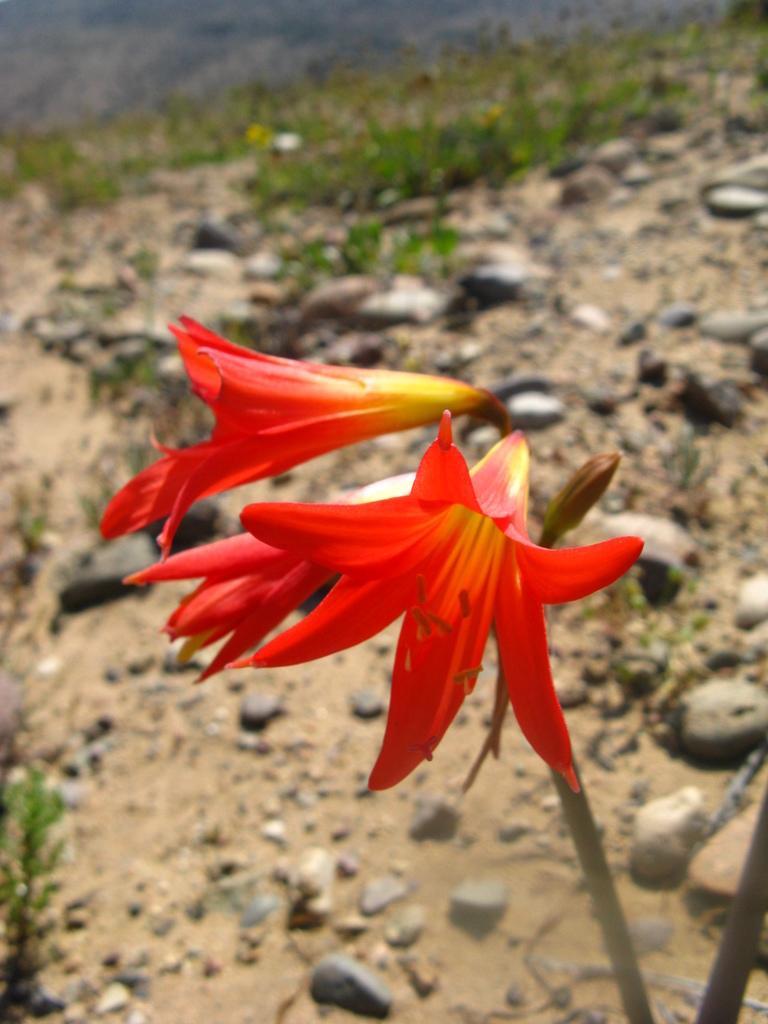Please provide a concise description of this image. In the middle of the image we can see few flowers, in the background we can find few stones and grass. 